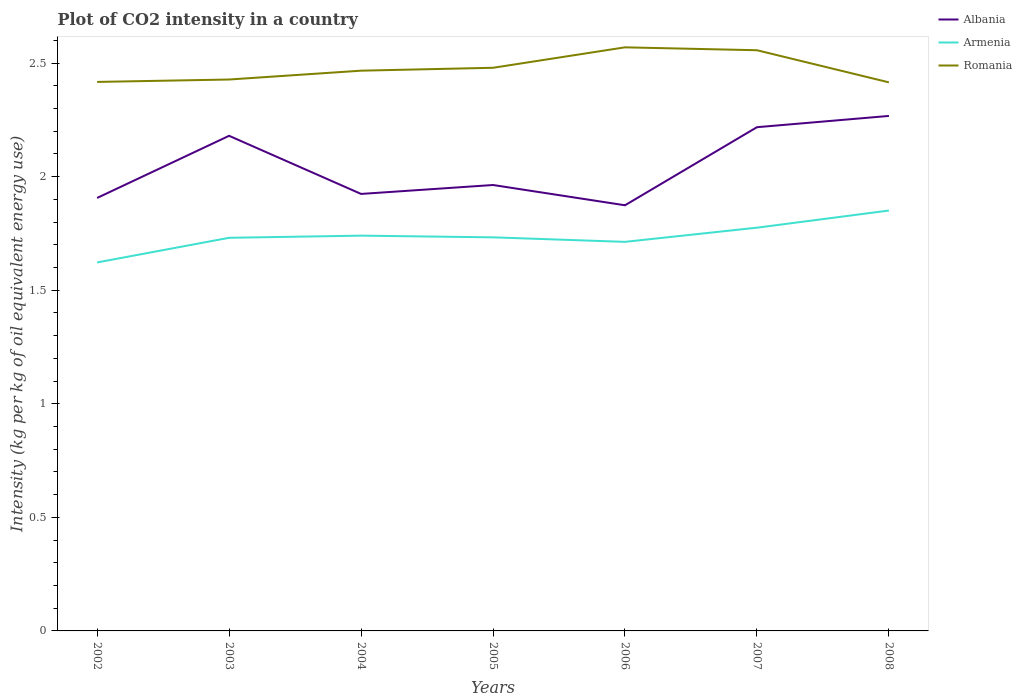How many different coloured lines are there?
Ensure brevity in your answer.  3. Across all years, what is the maximum CO2 intensity in in Romania?
Give a very brief answer. 2.41. What is the total CO2 intensity in in Albania in the graph?
Make the answer very short. -0.27. What is the difference between the highest and the second highest CO2 intensity in in Armenia?
Provide a short and direct response. 0.23. What is the difference between the highest and the lowest CO2 intensity in in Romania?
Your answer should be compact. 3. What is the difference between two consecutive major ticks on the Y-axis?
Offer a very short reply. 0.5. Are the values on the major ticks of Y-axis written in scientific E-notation?
Ensure brevity in your answer.  No. Does the graph contain grids?
Offer a terse response. No. What is the title of the graph?
Provide a short and direct response. Plot of CO2 intensity in a country. What is the label or title of the Y-axis?
Your response must be concise. Intensity (kg per kg of oil equivalent energy use). What is the Intensity (kg per kg of oil equivalent energy use) in Albania in 2002?
Make the answer very short. 1.91. What is the Intensity (kg per kg of oil equivalent energy use) of Armenia in 2002?
Your answer should be very brief. 1.62. What is the Intensity (kg per kg of oil equivalent energy use) of Romania in 2002?
Ensure brevity in your answer.  2.42. What is the Intensity (kg per kg of oil equivalent energy use) in Albania in 2003?
Your response must be concise. 2.18. What is the Intensity (kg per kg of oil equivalent energy use) of Armenia in 2003?
Offer a very short reply. 1.73. What is the Intensity (kg per kg of oil equivalent energy use) of Romania in 2003?
Provide a short and direct response. 2.43. What is the Intensity (kg per kg of oil equivalent energy use) in Albania in 2004?
Provide a short and direct response. 1.92. What is the Intensity (kg per kg of oil equivalent energy use) of Armenia in 2004?
Give a very brief answer. 1.74. What is the Intensity (kg per kg of oil equivalent energy use) of Romania in 2004?
Keep it short and to the point. 2.47. What is the Intensity (kg per kg of oil equivalent energy use) of Albania in 2005?
Offer a very short reply. 1.96. What is the Intensity (kg per kg of oil equivalent energy use) in Armenia in 2005?
Your answer should be very brief. 1.73. What is the Intensity (kg per kg of oil equivalent energy use) in Romania in 2005?
Your answer should be very brief. 2.48. What is the Intensity (kg per kg of oil equivalent energy use) of Albania in 2006?
Keep it short and to the point. 1.87. What is the Intensity (kg per kg of oil equivalent energy use) of Armenia in 2006?
Offer a very short reply. 1.71. What is the Intensity (kg per kg of oil equivalent energy use) in Romania in 2006?
Keep it short and to the point. 2.57. What is the Intensity (kg per kg of oil equivalent energy use) of Albania in 2007?
Your answer should be very brief. 2.22. What is the Intensity (kg per kg of oil equivalent energy use) of Armenia in 2007?
Provide a succinct answer. 1.78. What is the Intensity (kg per kg of oil equivalent energy use) of Romania in 2007?
Ensure brevity in your answer.  2.56. What is the Intensity (kg per kg of oil equivalent energy use) of Albania in 2008?
Keep it short and to the point. 2.27. What is the Intensity (kg per kg of oil equivalent energy use) in Armenia in 2008?
Your response must be concise. 1.85. What is the Intensity (kg per kg of oil equivalent energy use) in Romania in 2008?
Give a very brief answer. 2.41. Across all years, what is the maximum Intensity (kg per kg of oil equivalent energy use) in Albania?
Your answer should be compact. 2.27. Across all years, what is the maximum Intensity (kg per kg of oil equivalent energy use) in Armenia?
Offer a very short reply. 1.85. Across all years, what is the maximum Intensity (kg per kg of oil equivalent energy use) in Romania?
Your response must be concise. 2.57. Across all years, what is the minimum Intensity (kg per kg of oil equivalent energy use) of Albania?
Offer a very short reply. 1.87. Across all years, what is the minimum Intensity (kg per kg of oil equivalent energy use) of Armenia?
Offer a terse response. 1.62. Across all years, what is the minimum Intensity (kg per kg of oil equivalent energy use) in Romania?
Your answer should be compact. 2.41. What is the total Intensity (kg per kg of oil equivalent energy use) of Albania in the graph?
Offer a very short reply. 14.33. What is the total Intensity (kg per kg of oil equivalent energy use) of Armenia in the graph?
Ensure brevity in your answer.  12.16. What is the total Intensity (kg per kg of oil equivalent energy use) in Romania in the graph?
Offer a terse response. 17.33. What is the difference between the Intensity (kg per kg of oil equivalent energy use) of Albania in 2002 and that in 2003?
Your response must be concise. -0.27. What is the difference between the Intensity (kg per kg of oil equivalent energy use) in Armenia in 2002 and that in 2003?
Your answer should be compact. -0.11. What is the difference between the Intensity (kg per kg of oil equivalent energy use) of Romania in 2002 and that in 2003?
Give a very brief answer. -0.01. What is the difference between the Intensity (kg per kg of oil equivalent energy use) in Albania in 2002 and that in 2004?
Your answer should be very brief. -0.02. What is the difference between the Intensity (kg per kg of oil equivalent energy use) of Armenia in 2002 and that in 2004?
Give a very brief answer. -0.12. What is the difference between the Intensity (kg per kg of oil equivalent energy use) of Romania in 2002 and that in 2004?
Your answer should be compact. -0.05. What is the difference between the Intensity (kg per kg of oil equivalent energy use) in Albania in 2002 and that in 2005?
Ensure brevity in your answer.  -0.06. What is the difference between the Intensity (kg per kg of oil equivalent energy use) of Armenia in 2002 and that in 2005?
Offer a very short reply. -0.11. What is the difference between the Intensity (kg per kg of oil equivalent energy use) of Romania in 2002 and that in 2005?
Give a very brief answer. -0.06. What is the difference between the Intensity (kg per kg of oil equivalent energy use) in Albania in 2002 and that in 2006?
Make the answer very short. 0.03. What is the difference between the Intensity (kg per kg of oil equivalent energy use) in Armenia in 2002 and that in 2006?
Offer a very short reply. -0.09. What is the difference between the Intensity (kg per kg of oil equivalent energy use) of Romania in 2002 and that in 2006?
Provide a short and direct response. -0.15. What is the difference between the Intensity (kg per kg of oil equivalent energy use) of Albania in 2002 and that in 2007?
Offer a very short reply. -0.31. What is the difference between the Intensity (kg per kg of oil equivalent energy use) of Armenia in 2002 and that in 2007?
Give a very brief answer. -0.15. What is the difference between the Intensity (kg per kg of oil equivalent energy use) of Romania in 2002 and that in 2007?
Your answer should be very brief. -0.14. What is the difference between the Intensity (kg per kg of oil equivalent energy use) in Albania in 2002 and that in 2008?
Offer a terse response. -0.36. What is the difference between the Intensity (kg per kg of oil equivalent energy use) in Armenia in 2002 and that in 2008?
Offer a terse response. -0.23. What is the difference between the Intensity (kg per kg of oil equivalent energy use) of Romania in 2002 and that in 2008?
Provide a short and direct response. 0. What is the difference between the Intensity (kg per kg of oil equivalent energy use) of Albania in 2003 and that in 2004?
Make the answer very short. 0.26. What is the difference between the Intensity (kg per kg of oil equivalent energy use) in Armenia in 2003 and that in 2004?
Offer a terse response. -0.01. What is the difference between the Intensity (kg per kg of oil equivalent energy use) in Romania in 2003 and that in 2004?
Provide a succinct answer. -0.04. What is the difference between the Intensity (kg per kg of oil equivalent energy use) in Albania in 2003 and that in 2005?
Offer a very short reply. 0.22. What is the difference between the Intensity (kg per kg of oil equivalent energy use) in Armenia in 2003 and that in 2005?
Your answer should be compact. -0. What is the difference between the Intensity (kg per kg of oil equivalent energy use) of Romania in 2003 and that in 2005?
Give a very brief answer. -0.05. What is the difference between the Intensity (kg per kg of oil equivalent energy use) in Albania in 2003 and that in 2006?
Ensure brevity in your answer.  0.31. What is the difference between the Intensity (kg per kg of oil equivalent energy use) in Armenia in 2003 and that in 2006?
Keep it short and to the point. 0.02. What is the difference between the Intensity (kg per kg of oil equivalent energy use) of Romania in 2003 and that in 2006?
Provide a short and direct response. -0.14. What is the difference between the Intensity (kg per kg of oil equivalent energy use) in Albania in 2003 and that in 2007?
Offer a terse response. -0.04. What is the difference between the Intensity (kg per kg of oil equivalent energy use) of Armenia in 2003 and that in 2007?
Your response must be concise. -0.04. What is the difference between the Intensity (kg per kg of oil equivalent energy use) of Romania in 2003 and that in 2007?
Your response must be concise. -0.13. What is the difference between the Intensity (kg per kg of oil equivalent energy use) of Albania in 2003 and that in 2008?
Offer a terse response. -0.09. What is the difference between the Intensity (kg per kg of oil equivalent energy use) of Armenia in 2003 and that in 2008?
Provide a short and direct response. -0.12. What is the difference between the Intensity (kg per kg of oil equivalent energy use) of Romania in 2003 and that in 2008?
Offer a terse response. 0.01. What is the difference between the Intensity (kg per kg of oil equivalent energy use) of Albania in 2004 and that in 2005?
Provide a short and direct response. -0.04. What is the difference between the Intensity (kg per kg of oil equivalent energy use) in Armenia in 2004 and that in 2005?
Ensure brevity in your answer.  0.01. What is the difference between the Intensity (kg per kg of oil equivalent energy use) of Romania in 2004 and that in 2005?
Offer a terse response. -0.01. What is the difference between the Intensity (kg per kg of oil equivalent energy use) in Albania in 2004 and that in 2006?
Give a very brief answer. 0.05. What is the difference between the Intensity (kg per kg of oil equivalent energy use) of Armenia in 2004 and that in 2006?
Offer a terse response. 0.03. What is the difference between the Intensity (kg per kg of oil equivalent energy use) in Romania in 2004 and that in 2006?
Make the answer very short. -0.1. What is the difference between the Intensity (kg per kg of oil equivalent energy use) of Albania in 2004 and that in 2007?
Offer a terse response. -0.29. What is the difference between the Intensity (kg per kg of oil equivalent energy use) of Armenia in 2004 and that in 2007?
Make the answer very short. -0.04. What is the difference between the Intensity (kg per kg of oil equivalent energy use) in Romania in 2004 and that in 2007?
Your answer should be compact. -0.09. What is the difference between the Intensity (kg per kg of oil equivalent energy use) in Albania in 2004 and that in 2008?
Your answer should be very brief. -0.34. What is the difference between the Intensity (kg per kg of oil equivalent energy use) of Armenia in 2004 and that in 2008?
Provide a short and direct response. -0.11. What is the difference between the Intensity (kg per kg of oil equivalent energy use) in Romania in 2004 and that in 2008?
Ensure brevity in your answer.  0.05. What is the difference between the Intensity (kg per kg of oil equivalent energy use) of Albania in 2005 and that in 2006?
Keep it short and to the point. 0.09. What is the difference between the Intensity (kg per kg of oil equivalent energy use) of Armenia in 2005 and that in 2006?
Keep it short and to the point. 0.02. What is the difference between the Intensity (kg per kg of oil equivalent energy use) of Romania in 2005 and that in 2006?
Provide a short and direct response. -0.09. What is the difference between the Intensity (kg per kg of oil equivalent energy use) of Albania in 2005 and that in 2007?
Make the answer very short. -0.25. What is the difference between the Intensity (kg per kg of oil equivalent energy use) in Armenia in 2005 and that in 2007?
Make the answer very short. -0.04. What is the difference between the Intensity (kg per kg of oil equivalent energy use) of Romania in 2005 and that in 2007?
Give a very brief answer. -0.08. What is the difference between the Intensity (kg per kg of oil equivalent energy use) in Albania in 2005 and that in 2008?
Provide a short and direct response. -0.3. What is the difference between the Intensity (kg per kg of oil equivalent energy use) of Armenia in 2005 and that in 2008?
Your answer should be compact. -0.12. What is the difference between the Intensity (kg per kg of oil equivalent energy use) in Romania in 2005 and that in 2008?
Provide a succinct answer. 0.06. What is the difference between the Intensity (kg per kg of oil equivalent energy use) in Albania in 2006 and that in 2007?
Ensure brevity in your answer.  -0.34. What is the difference between the Intensity (kg per kg of oil equivalent energy use) of Armenia in 2006 and that in 2007?
Provide a short and direct response. -0.06. What is the difference between the Intensity (kg per kg of oil equivalent energy use) in Romania in 2006 and that in 2007?
Provide a short and direct response. 0.01. What is the difference between the Intensity (kg per kg of oil equivalent energy use) in Albania in 2006 and that in 2008?
Your answer should be compact. -0.39. What is the difference between the Intensity (kg per kg of oil equivalent energy use) of Armenia in 2006 and that in 2008?
Your answer should be compact. -0.14. What is the difference between the Intensity (kg per kg of oil equivalent energy use) of Romania in 2006 and that in 2008?
Keep it short and to the point. 0.15. What is the difference between the Intensity (kg per kg of oil equivalent energy use) in Albania in 2007 and that in 2008?
Offer a terse response. -0.05. What is the difference between the Intensity (kg per kg of oil equivalent energy use) in Armenia in 2007 and that in 2008?
Keep it short and to the point. -0.08. What is the difference between the Intensity (kg per kg of oil equivalent energy use) in Romania in 2007 and that in 2008?
Provide a short and direct response. 0.14. What is the difference between the Intensity (kg per kg of oil equivalent energy use) in Albania in 2002 and the Intensity (kg per kg of oil equivalent energy use) in Armenia in 2003?
Make the answer very short. 0.18. What is the difference between the Intensity (kg per kg of oil equivalent energy use) of Albania in 2002 and the Intensity (kg per kg of oil equivalent energy use) of Romania in 2003?
Offer a very short reply. -0.52. What is the difference between the Intensity (kg per kg of oil equivalent energy use) of Armenia in 2002 and the Intensity (kg per kg of oil equivalent energy use) of Romania in 2003?
Your response must be concise. -0.81. What is the difference between the Intensity (kg per kg of oil equivalent energy use) in Albania in 2002 and the Intensity (kg per kg of oil equivalent energy use) in Armenia in 2004?
Ensure brevity in your answer.  0.17. What is the difference between the Intensity (kg per kg of oil equivalent energy use) in Albania in 2002 and the Intensity (kg per kg of oil equivalent energy use) in Romania in 2004?
Your response must be concise. -0.56. What is the difference between the Intensity (kg per kg of oil equivalent energy use) of Armenia in 2002 and the Intensity (kg per kg of oil equivalent energy use) of Romania in 2004?
Offer a very short reply. -0.84. What is the difference between the Intensity (kg per kg of oil equivalent energy use) in Albania in 2002 and the Intensity (kg per kg of oil equivalent energy use) in Armenia in 2005?
Keep it short and to the point. 0.17. What is the difference between the Intensity (kg per kg of oil equivalent energy use) in Albania in 2002 and the Intensity (kg per kg of oil equivalent energy use) in Romania in 2005?
Keep it short and to the point. -0.57. What is the difference between the Intensity (kg per kg of oil equivalent energy use) of Armenia in 2002 and the Intensity (kg per kg of oil equivalent energy use) of Romania in 2005?
Offer a very short reply. -0.86. What is the difference between the Intensity (kg per kg of oil equivalent energy use) in Albania in 2002 and the Intensity (kg per kg of oil equivalent energy use) in Armenia in 2006?
Provide a short and direct response. 0.19. What is the difference between the Intensity (kg per kg of oil equivalent energy use) in Albania in 2002 and the Intensity (kg per kg of oil equivalent energy use) in Romania in 2006?
Your answer should be compact. -0.66. What is the difference between the Intensity (kg per kg of oil equivalent energy use) in Armenia in 2002 and the Intensity (kg per kg of oil equivalent energy use) in Romania in 2006?
Your response must be concise. -0.95. What is the difference between the Intensity (kg per kg of oil equivalent energy use) of Albania in 2002 and the Intensity (kg per kg of oil equivalent energy use) of Armenia in 2007?
Make the answer very short. 0.13. What is the difference between the Intensity (kg per kg of oil equivalent energy use) in Albania in 2002 and the Intensity (kg per kg of oil equivalent energy use) in Romania in 2007?
Ensure brevity in your answer.  -0.65. What is the difference between the Intensity (kg per kg of oil equivalent energy use) of Armenia in 2002 and the Intensity (kg per kg of oil equivalent energy use) of Romania in 2007?
Provide a succinct answer. -0.93. What is the difference between the Intensity (kg per kg of oil equivalent energy use) in Albania in 2002 and the Intensity (kg per kg of oil equivalent energy use) in Armenia in 2008?
Make the answer very short. 0.06. What is the difference between the Intensity (kg per kg of oil equivalent energy use) in Albania in 2002 and the Intensity (kg per kg of oil equivalent energy use) in Romania in 2008?
Give a very brief answer. -0.51. What is the difference between the Intensity (kg per kg of oil equivalent energy use) in Armenia in 2002 and the Intensity (kg per kg of oil equivalent energy use) in Romania in 2008?
Your response must be concise. -0.79. What is the difference between the Intensity (kg per kg of oil equivalent energy use) in Albania in 2003 and the Intensity (kg per kg of oil equivalent energy use) in Armenia in 2004?
Provide a succinct answer. 0.44. What is the difference between the Intensity (kg per kg of oil equivalent energy use) in Albania in 2003 and the Intensity (kg per kg of oil equivalent energy use) in Romania in 2004?
Your answer should be compact. -0.29. What is the difference between the Intensity (kg per kg of oil equivalent energy use) of Armenia in 2003 and the Intensity (kg per kg of oil equivalent energy use) of Romania in 2004?
Offer a very short reply. -0.74. What is the difference between the Intensity (kg per kg of oil equivalent energy use) in Albania in 2003 and the Intensity (kg per kg of oil equivalent energy use) in Armenia in 2005?
Provide a succinct answer. 0.45. What is the difference between the Intensity (kg per kg of oil equivalent energy use) in Albania in 2003 and the Intensity (kg per kg of oil equivalent energy use) in Romania in 2005?
Your answer should be compact. -0.3. What is the difference between the Intensity (kg per kg of oil equivalent energy use) of Armenia in 2003 and the Intensity (kg per kg of oil equivalent energy use) of Romania in 2005?
Offer a terse response. -0.75. What is the difference between the Intensity (kg per kg of oil equivalent energy use) of Albania in 2003 and the Intensity (kg per kg of oil equivalent energy use) of Armenia in 2006?
Ensure brevity in your answer.  0.47. What is the difference between the Intensity (kg per kg of oil equivalent energy use) in Albania in 2003 and the Intensity (kg per kg of oil equivalent energy use) in Romania in 2006?
Ensure brevity in your answer.  -0.39. What is the difference between the Intensity (kg per kg of oil equivalent energy use) in Armenia in 2003 and the Intensity (kg per kg of oil equivalent energy use) in Romania in 2006?
Your response must be concise. -0.84. What is the difference between the Intensity (kg per kg of oil equivalent energy use) of Albania in 2003 and the Intensity (kg per kg of oil equivalent energy use) of Armenia in 2007?
Provide a short and direct response. 0.4. What is the difference between the Intensity (kg per kg of oil equivalent energy use) of Albania in 2003 and the Intensity (kg per kg of oil equivalent energy use) of Romania in 2007?
Provide a short and direct response. -0.38. What is the difference between the Intensity (kg per kg of oil equivalent energy use) of Armenia in 2003 and the Intensity (kg per kg of oil equivalent energy use) of Romania in 2007?
Make the answer very short. -0.83. What is the difference between the Intensity (kg per kg of oil equivalent energy use) of Albania in 2003 and the Intensity (kg per kg of oil equivalent energy use) of Armenia in 2008?
Offer a terse response. 0.33. What is the difference between the Intensity (kg per kg of oil equivalent energy use) of Albania in 2003 and the Intensity (kg per kg of oil equivalent energy use) of Romania in 2008?
Make the answer very short. -0.24. What is the difference between the Intensity (kg per kg of oil equivalent energy use) in Armenia in 2003 and the Intensity (kg per kg of oil equivalent energy use) in Romania in 2008?
Provide a short and direct response. -0.68. What is the difference between the Intensity (kg per kg of oil equivalent energy use) of Albania in 2004 and the Intensity (kg per kg of oil equivalent energy use) of Armenia in 2005?
Give a very brief answer. 0.19. What is the difference between the Intensity (kg per kg of oil equivalent energy use) of Albania in 2004 and the Intensity (kg per kg of oil equivalent energy use) of Romania in 2005?
Offer a very short reply. -0.56. What is the difference between the Intensity (kg per kg of oil equivalent energy use) of Armenia in 2004 and the Intensity (kg per kg of oil equivalent energy use) of Romania in 2005?
Provide a short and direct response. -0.74. What is the difference between the Intensity (kg per kg of oil equivalent energy use) in Albania in 2004 and the Intensity (kg per kg of oil equivalent energy use) in Armenia in 2006?
Ensure brevity in your answer.  0.21. What is the difference between the Intensity (kg per kg of oil equivalent energy use) in Albania in 2004 and the Intensity (kg per kg of oil equivalent energy use) in Romania in 2006?
Make the answer very short. -0.65. What is the difference between the Intensity (kg per kg of oil equivalent energy use) in Armenia in 2004 and the Intensity (kg per kg of oil equivalent energy use) in Romania in 2006?
Keep it short and to the point. -0.83. What is the difference between the Intensity (kg per kg of oil equivalent energy use) in Albania in 2004 and the Intensity (kg per kg of oil equivalent energy use) in Armenia in 2007?
Make the answer very short. 0.15. What is the difference between the Intensity (kg per kg of oil equivalent energy use) in Albania in 2004 and the Intensity (kg per kg of oil equivalent energy use) in Romania in 2007?
Provide a succinct answer. -0.63. What is the difference between the Intensity (kg per kg of oil equivalent energy use) in Armenia in 2004 and the Intensity (kg per kg of oil equivalent energy use) in Romania in 2007?
Give a very brief answer. -0.82. What is the difference between the Intensity (kg per kg of oil equivalent energy use) of Albania in 2004 and the Intensity (kg per kg of oil equivalent energy use) of Armenia in 2008?
Keep it short and to the point. 0.07. What is the difference between the Intensity (kg per kg of oil equivalent energy use) of Albania in 2004 and the Intensity (kg per kg of oil equivalent energy use) of Romania in 2008?
Your response must be concise. -0.49. What is the difference between the Intensity (kg per kg of oil equivalent energy use) of Armenia in 2004 and the Intensity (kg per kg of oil equivalent energy use) of Romania in 2008?
Make the answer very short. -0.67. What is the difference between the Intensity (kg per kg of oil equivalent energy use) in Albania in 2005 and the Intensity (kg per kg of oil equivalent energy use) in Armenia in 2006?
Make the answer very short. 0.25. What is the difference between the Intensity (kg per kg of oil equivalent energy use) in Albania in 2005 and the Intensity (kg per kg of oil equivalent energy use) in Romania in 2006?
Offer a terse response. -0.61. What is the difference between the Intensity (kg per kg of oil equivalent energy use) in Armenia in 2005 and the Intensity (kg per kg of oil equivalent energy use) in Romania in 2006?
Your answer should be compact. -0.84. What is the difference between the Intensity (kg per kg of oil equivalent energy use) in Albania in 2005 and the Intensity (kg per kg of oil equivalent energy use) in Armenia in 2007?
Provide a succinct answer. 0.19. What is the difference between the Intensity (kg per kg of oil equivalent energy use) in Albania in 2005 and the Intensity (kg per kg of oil equivalent energy use) in Romania in 2007?
Your answer should be compact. -0.59. What is the difference between the Intensity (kg per kg of oil equivalent energy use) of Armenia in 2005 and the Intensity (kg per kg of oil equivalent energy use) of Romania in 2007?
Provide a short and direct response. -0.82. What is the difference between the Intensity (kg per kg of oil equivalent energy use) of Albania in 2005 and the Intensity (kg per kg of oil equivalent energy use) of Armenia in 2008?
Provide a succinct answer. 0.11. What is the difference between the Intensity (kg per kg of oil equivalent energy use) in Albania in 2005 and the Intensity (kg per kg of oil equivalent energy use) in Romania in 2008?
Your response must be concise. -0.45. What is the difference between the Intensity (kg per kg of oil equivalent energy use) of Armenia in 2005 and the Intensity (kg per kg of oil equivalent energy use) of Romania in 2008?
Offer a terse response. -0.68. What is the difference between the Intensity (kg per kg of oil equivalent energy use) of Albania in 2006 and the Intensity (kg per kg of oil equivalent energy use) of Armenia in 2007?
Your answer should be very brief. 0.1. What is the difference between the Intensity (kg per kg of oil equivalent energy use) of Albania in 2006 and the Intensity (kg per kg of oil equivalent energy use) of Romania in 2007?
Ensure brevity in your answer.  -0.68. What is the difference between the Intensity (kg per kg of oil equivalent energy use) in Armenia in 2006 and the Intensity (kg per kg of oil equivalent energy use) in Romania in 2007?
Give a very brief answer. -0.84. What is the difference between the Intensity (kg per kg of oil equivalent energy use) of Albania in 2006 and the Intensity (kg per kg of oil equivalent energy use) of Armenia in 2008?
Your answer should be very brief. 0.02. What is the difference between the Intensity (kg per kg of oil equivalent energy use) in Albania in 2006 and the Intensity (kg per kg of oil equivalent energy use) in Romania in 2008?
Provide a succinct answer. -0.54. What is the difference between the Intensity (kg per kg of oil equivalent energy use) in Armenia in 2006 and the Intensity (kg per kg of oil equivalent energy use) in Romania in 2008?
Provide a succinct answer. -0.7. What is the difference between the Intensity (kg per kg of oil equivalent energy use) of Albania in 2007 and the Intensity (kg per kg of oil equivalent energy use) of Armenia in 2008?
Provide a succinct answer. 0.37. What is the difference between the Intensity (kg per kg of oil equivalent energy use) in Albania in 2007 and the Intensity (kg per kg of oil equivalent energy use) in Romania in 2008?
Your answer should be compact. -0.2. What is the difference between the Intensity (kg per kg of oil equivalent energy use) of Armenia in 2007 and the Intensity (kg per kg of oil equivalent energy use) of Romania in 2008?
Offer a very short reply. -0.64. What is the average Intensity (kg per kg of oil equivalent energy use) of Albania per year?
Your answer should be compact. 2.05. What is the average Intensity (kg per kg of oil equivalent energy use) of Armenia per year?
Provide a succinct answer. 1.74. What is the average Intensity (kg per kg of oil equivalent energy use) of Romania per year?
Your response must be concise. 2.48. In the year 2002, what is the difference between the Intensity (kg per kg of oil equivalent energy use) in Albania and Intensity (kg per kg of oil equivalent energy use) in Armenia?
Offer a very short reply. 0.28. In the year 2002, what is the difference between the Intensity (kg per kg of oil equivalent energy use) of Albania and Intensity (kg per kg of oil equivalent energy use) of Romania?
Keep it short and to the point. -0.51. In the year 2002, what is the difference between the Intensity (kg per kg of oil equivalent energy use) of Armenia and Intensity (kg per kg of oil equivalent energy use) of Romania?
Your answer should be compact. -0.79. In the year 2003, what is the difference between the Intensity (kg per kg of oil equivalent energy use) of Albania and Intensity (kg per kg of oil equivalent energy use) of Armenia?
Ensure brevity in your answer.  0.45. In the year 2003, what is the difference between the Intensity (kg per kg of oil equivalent energy use) of Albania and Intensity (kg per kg of oil equivalent energy use) of Romania?
Provide a succinct answer. -0.25. In the year 2003, what is the difference between the Intensity (kg per kg of oil equivalent energy use) in Armenia and Intensity (kg per kg of oil equivalent energy use) in Romania?
Your response must be concise. -0.7. In the year 2004, what is the difference between the Intensity (kg per kg of oil equivalent energy use) of Albania and Intensity (kg per kg of oil equivalent energy use) of Armenia?
Provide a short and direct response. 0.18. In the year 2004, what is the difference between the Intensity (kg per kg of oil equivalent energy use) in Albania and Intensity (kg per kg of oil equivalent energy use) in Romania?
Provide a short and direct response. -0.54. In the year 2004, what is the difference between the Intensity (kg per kg of oil equivalent energy use) of Armenia and Intensity (kg per kg of oil equivalent energy use) of Romania?
Ensure brevity in your answer.  -0.73. In the year 2005, what is the difference between the Intensity (kg per kg of oil equivalent energy use) in Albania and Intensity (kg per kg of oil equivalent energy use) in Armenia?
Offer a very short reply. 0.23. In the year 2005, what is the difference between the Intensity (kg per kg of oil equivalent energy use) of Albania and Intensity (kg per kg of oil equivalent energy use) of Romania?
Offer a very short reply. -0.52. In the year 2005, what is the difference between the Intensity (kg per kg of oil equivalent energy use) in Armenia and Intensity (kg per kg of oil equivalent energy use) in Romania?
Offer a terse response. -0.75. In the year 2006, what is the difference between the Intensity (kg per kg of oil equivalent energy use) of Albania and Intensity (kg per kg of oil equivalent energy use) of Armenia?
Your answer should be compact. 0.16. In the year 2006, what is the difference between the Intensity (kg per kg of oil equivalent energy use) in Albania and Intensity (kg per kg of oil equivalent energy use) in Romania?
Offer a very short reply. -0.7. In the year 2006, what is the difference between the Intensity (kg per kg of oil equivalent energy use) in Armenia and Intensity (kg per kg of oil equivalent energy use) in Romania?
Provide a succinct answer. -0.86. In the year 2007, what is the difference between the Intensity (kg per kg of oil equivalent energy use) in Albania and Intensity (kg per kg of oil equivalent energy use) in Armenia?
Your response must be concise. 0.44. In the year 2007, what is the difference between the Intensity (kg per kg of oil equivalent energy use) of Albania and Intensity (kg per kg of oil equivalent energy use) of Romania?
Provide a short and direct response. -0.34. In the year 2007, what is the difference between the Intensity (kg per kg of oil equivalent energy use) of Armenia and Intensity (kg per kg of oil equivalent energy use) of Romania?
Give a very brief answer. -0.78. In the year 2008, what is the difference between the Intensity (kg per kg of oil equivalent energy use) of Albania and Intensity (kg per kg of oil equivalent energy use) of Armenia?
Give a very brief answer. 0.42. In the year 2008, what is the difference between the Intensity (kg per kg of oil equivalent energy use) of Albania and Intensity (kg per kg of oil equivalent energy use) of Romania?
Provide a succinct answer. -0.15. In the year 2008, what is the difference between the Intensity (kg per kg of oil equivalent energy use) of Armenia and Intensity (kg per kg of oil equivalent energy use) of Romania?
Provide a succinct answer. -0.56. What is the ratio of the Intensity (kg per kg of oil equivalent energy use) in Albania in 2002 to that in 2003?
Give a very brief answer. 0.87. What is the ratio of the Intensity (kg per kg of oil equivalent energy use) of Armenia in 2002 to that in 2003?
Ensure brevity in your answer.  0.94. What is the ratio of the Intensity (kg per kg of oil equivalent energy use) in Romania in 2002 to that in 2003?
Your answer should be very brief. 1. What is the ratio of the Intensity (kg per kg of oil equivalent energy use) of Albania in 2002 to that in 2004?
Offer a terse response. 0.99. What is the ratio of the Intensity (kg per kg of oil equivalent energy use) in Armenia in 2002 to that in 2004?
Provide a succinct answer. 0.93. What is the ratio of the Intensity (kg per kg of oil equivalent energy use) of Romania in 2002 to that in 2004?
Your answer should be compact. 0.98. What is the ratio of the Intensity (kg per kg of oil equivalent energy use) of Armenia in 2002 to that in 2005?
Give a very brief answer. 0.94. What is the ratio of the Intensity (kg per kg of oil equivalent energy use) in Romania in 2002 to that in 2005?
Keep it short and to the point. 0.97. What is the ratio of the Intensity (kg per kg of oil equivalent energy use) of Albania in 2002 to that in 2006?
Give a very brief answer. 1.02. What is the ratio of the Intensity (kg per kg of oil equivalent energy use) of Armenia in 2002 to that in 2006?
Your response must be concise. 0.95. What is the ratio of the Intensity (kg per kg of oil equivalent energy use) of Romania in 2002 to that in 2006?
Give a very brief answer. 0.94. What is the ratio of the Intensity (kg per kg of oil equivalent energy use) in Albania in 2002 to that in 2007?
Your answer should be very brief. 0.86. What is the ratio of the Intensity (kg per kg of oil equivalent energy use) of Armenia in 2002 to that in 2007?
Provide a short and direct response. 0.91. What is the ratio of the Intensity (kg per kg of oil equivalent energy use) of Romania in 2002 to that in 2007?
Your answer should be very brief. 0.95. What is the ratio of the Intensity (kg per kg of oil equivalent energy use) in Albania in 2002 to that in 2008?
Make the answer very short. 0.84. What is the ratio of the Intensity (kg per kg of oil equivalent energy use) in Armenia in 2002 to that in 2008?
Give a very brief answer. 0.88. What is the ratio of the Intensity (kg per kg of oil equivalent energy use) in Albania in 2003 to that in 2004?
Your answer should be very brief. 1.13. What is the ratio of the Intensity (kg per kg of oil equivalent energy use) in Romania in 2003 to that in 2004?
Offer a terse response. 0.98. What is the ratio of the Intensity (kg per kg of oil equivalent energy use) of Albania in 2003 to that in 2005?
Make the answer very short. 1.11. What is the ratio of the Intensity (kg per kg of oil equivalent energy use) of Armenia in 2003 to that in 2005?
Offer a very short reply. 1. What is the ratio of the Intensity (kg per kg of oil equivalent energy use) in Romania in 2003 to that in 2005?
Your answer should be compact. 0.98. What is the ratio of the Intensity (kg per kg of oil equivalent energy use) in Albania in 2003 to that in 2006?
Offer a very short reply. 1.16. What is the ratio of the Intensity (kg per kg of oil equivalent energy use) of Armenia in 2003 to that in 2006?
Your answer should be compact. 1.01. What is the ratio of the Intensity (kg per kg of oil equivalent energy use) of Romania in 2003 to that in 2006?
Provide a succinct answer. 0.94. What is the ratio of the Intensity (kg per kg of oil equivalent energy use) of Albania in 2003 to that in 2007?
Ensure brevity in your answer.  0.98. What is the ratio of the Intensity (kg per kg of oil equivalent energy use) of Armenia in 2003 to that in 2007?
Give a very brief answer. 0.97. What is the ratio of the Intensity (kg per kg of oil equivalent energy use) in Romania in 2003 to that in 2007?
Make the answer very short. 0.95. What is the ratio of the Intensity (kg per kg of oil equivalent energy use) in Albania in 2003 to that in 2008?
Provide a succinct answer. 0.96. What is the ratio of the Intensity (kg per kg of oil equivalent energy use) of Armenia in 2003 to that in 2008?
Offer a very short reply. 0.94. What is the ratio of the Intensity (kg per kg of oil equivalent energy use) in Romania in 2003 to that in 2008?
Offer a very short reply. 1.01. What is the ratio of the Intensity (kg per kg of oil equivalent energy use) of Armenia in 2004 to that in 2005?
Make the answer very short. 1. What is the ratio of the Intensity (kg per kg of oil equivalent energy use) of Romania in 2004 to that in 2005?
Offer a terse response. 0.99. What is the ratio of the Intensity (kg per kg of oil equivalent energy use) in Albania in 2004 to that in 2006?
Keep it short and to the point. 1.03. What is the ratio of the Intensity (kg per kg of oil equivalent energy use) in Albania in 2004 to that in 2007?
Offer a terse response. 0.87. What is the ratio of the Intensity (kg per kg of oil equivalent energy use) in Armenia in 2004 to that in 2007?
Offer a very short reply. 0.98. What is the ratio of the Intensity (kg per kg of oil equivalent energy use) in Romania in 2004 to that in 2007?
Provide a succinct answer. 0.96. What is the ratio of the Intensity (kg per kg of oil equivalent energy use) in Albania in 2004 to that in 2008?
Offer a very short reply. 0.85. What is the ratio of the Intensity (kg per kg of oil equivalent energy use) in Armenia in 2004 to that in 2008?
Keep it short and to the point. 0.94. What is the ratio of the Intensity (kg per kg of oil equivalent energy use) of Romania in 2004 to that in 2008?
Offer a very short reply. 1.02. What is the ratio of the Intensity (kg per kg of oil equivalent energy use) of Albania in 2005 to that in 2006?
Offer a very short reply. 1.05. What is the ratio of the Intensity (kg per kg of oil equivalent energy use) of Armenia in 2005 to that in 2006?
Provide a short and direct response. 1.01. What is the ratio of the Intensity (kg per kg of oil equivalent energy use) in Romania in 2005 to that in 2006?
Make the answer very short. 0.96. What is the ratio of the Intensity (kg per kg of oil equivalent energy use) of Albania in 2005 to that in 2007?
Ensure brevity in your answer.  0.89. What is the ratio of the Intensity (kg per kg of oil equivalent energy use) of Armenia in 2005 to that in 2007?
Your answer should be very brief. 0.98. What is the ratio of the Intensity (kg per kg of oil equivalent energy use) in Romania in 2005 to that in 2007?
Offer a terse response. 0.97. What is the ratio of the Intensity (kg per kg of oil equivalent energy use) in Albania in 2005 to that in 2008?
Offer a very short reply. 0.87. What is the ratio of the Intensity (kg per kg of oil equivalent energy use) of Armenia in 2005 to that in 2008?
Offer a very short reply. 0.94. What is the ratio of the Intensity (kg per kg of oil equivalent energy use) in Romania in 2005 to that in 2008?
Make the answer very short. 1.03. What is the ratio of the Intensity (kg per kg of oil equivalent energy use) in Albania in 2006 to that in 2007?
Your answer should be compact. 0.84. What is the ratio of the Intensity (kg per kg of oil equivalent energy use) in Armenia in 2006 to that in 2007?
Ensure brevity in your answer.  0.96. What is the ratio of the Intensity (kg per kg of oil equivalent energy use) in Romania in 2006 to that in 2007?
Your answer should be compact. 1. What is the ratio of the Intensity (kg per kg of oil equivalent energy use) of Albania in 2006 to that in 2008?
Your answer should be compact. 0.83. What is the ratio of the Intensity (kg per kg of oil equivalent energy use) in Armenia in 2006 to that in 2008?
Your answer should be compact. 0.93. What is the ratio of the Intensity (kg per kg of oil equivalent energy use) of Romania in 2006 to that in 2008?
Provide a short and direct response. 1.06. What is the ratio of the Intensity (kg per kg of oil equivalent energy use) of Albania in 2007 to that in 2008?
Keep it short and to the point. 0.98. What is the ratio of the Intensity (kg per kg of oil equivalent energy use) in Armenia in 2007 to that in 2008?
Your answer should be compact. 0.96. What is the ratio of the Intensity (kg per kg of oil equivalent energy use) in Romania in 2007 to that in 2008?
Give a very brief answer. 1.06. What is the difference between the highest and the second highest Intensity (kg per kg of oil equivalent energy use) of Albania?
Provide a succinct answer. 0.05. What is the difference between the highest and the second highest Intensity (kg per kg of oil equivalent energy use) of Armenia?
Your response must be concise. 0.08. What is the difference between the highest and the second highest Intensity (kg per kg of oil equivalent energy use) of Romania?
Make the answer very short. 0.01. What is the difference between the highest and the lowest Intensity (kg per kg of oil equivalent energy use) of Albania?
Keep it short and to the point. 0.39. What is the difference between the highest and the lowest Intensity (kg per kg of oil equivalent energy use) of Armenia?
Provide a short and direct response. 0.23. What is the difference between the highest and the lowest Intensity (kg per kg of oil equivalent energy use) in Romania?
Your answer should be very brief. 0.15. 